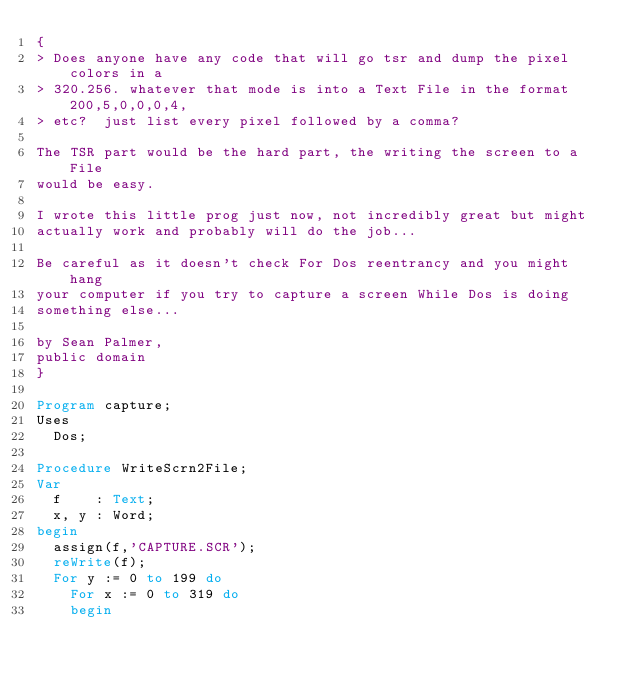Convert code to text. <code><loc_0><loc_0><loc_500><loc_500><_Pascal_>{
> Does anyone have any code that will go tsr and dump the pixel colors in a
> 320.256. whatever that mode is into a Text File in the format 200,5,0,0,0,4,
> etc?  just list every pixel followed by a comma?

The TSR part would be the hard part, the writing the screen to a File
would be easy.

I wrote this little prog just now, not incredibly great but might
actually work and probably will do the job...

Be careful as it doesn't check For Dos reentrancy and you might hang
your computer if you try to capture a screen While Dos is doing
something else...

by Sean Palmer,
public domain
}

Program capture;
Uses
  Dos;

Procedure WriteScrn2File;
Var
  f    : Text;
  x, y : Word;
begin
  assign(f,'CAPTURE.SCR');
  reWrite(f);
  For y := 0 to 199 do
    For x := 0 to 319 do
    begin</code> 